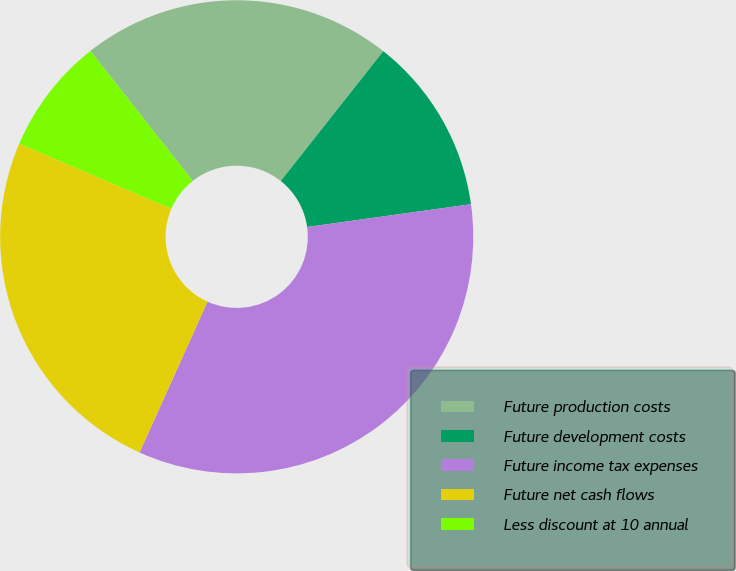<chart> <loc_0><loc_0><loc_500><loc_500><pie_chart><fcel>Future production costs<fcel>Future development costs<fcel>Future income tax expenses<fcel>Future net cash flows<fcel>Less discount at 10 annual<nl><fcel>21.26%<fcel>12.16%<fcel>33.94%<fcel>24.71%<fcel>7.94%<nl></chart> 